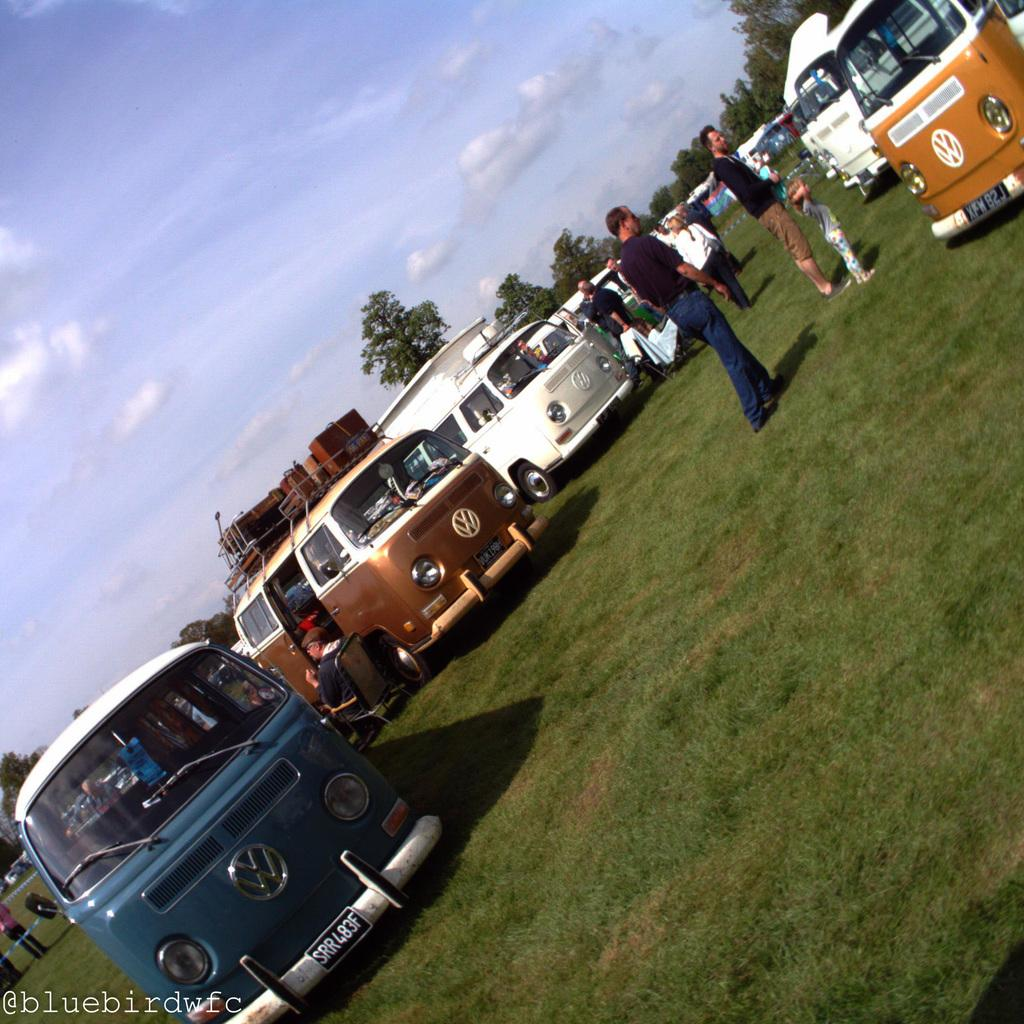What type of vegetation is visible in the front of the image? There is grass in the front of the image. What can be seen in the center of the image? There are vehicles in the center of the image. What are the people in the image doing? There are persons standing and sitting in the image. What can be seen in the background of the image? There are trees in the background of the image. What is the condition of the sky in the image? The sky is cloudy in the image. Can you see a wall surrounding the vehicles in the image? There is no mention of a wall in the image; it only describes grass, vehicles, persons, trees, and a cloudy sky. What type of net is being used by the persons in the image? There is no mention of a net in the image; it only describes grass, vehicles, persons, trees, and a cloudy sky. 